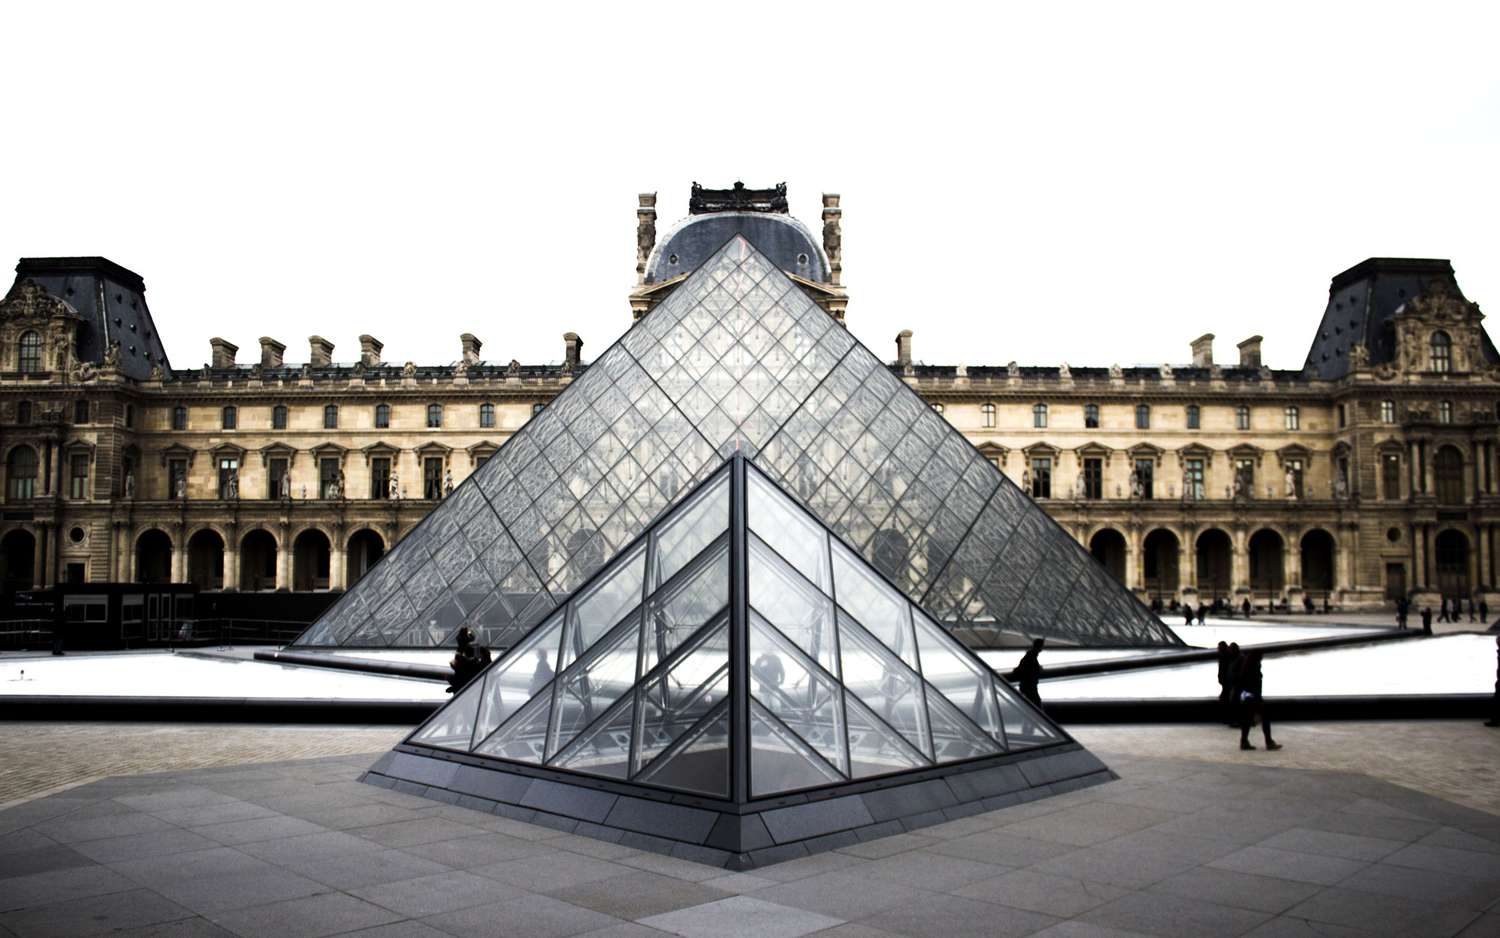Write a detailed description of the given image. This captivating image showcases the iconic Louvre Museum in Paris, France. Dominating the scene is the famous glass pyramid, a stunning architectural blend of modernity amidst the historical Louvre Palace. The pyramid, constructed from sleek glass and metal, stands tall in the courtyard, its sharp, geometric lines contrasting beautifully with the more ornate historical architecture surrounding it. 

A calm pool of water encircles the pyramid, lending a serene ambiance to the otherwise lively museum grounds. As we look deeper into the background, the grandeur of the Louvre Palace unfolds with its classic and intricate design, a testament to centuries of history and art. Despite the overcast sky overhead, the scene exudes vibrancy and life, with several visitors adding a dynamic human element to this serene tableau. This portrayal of the Louvre encapsulates its unique fusion of historical elegance and contemporary design, providing a comprehensive glimpse into one of the world's most renowned landmarks. 